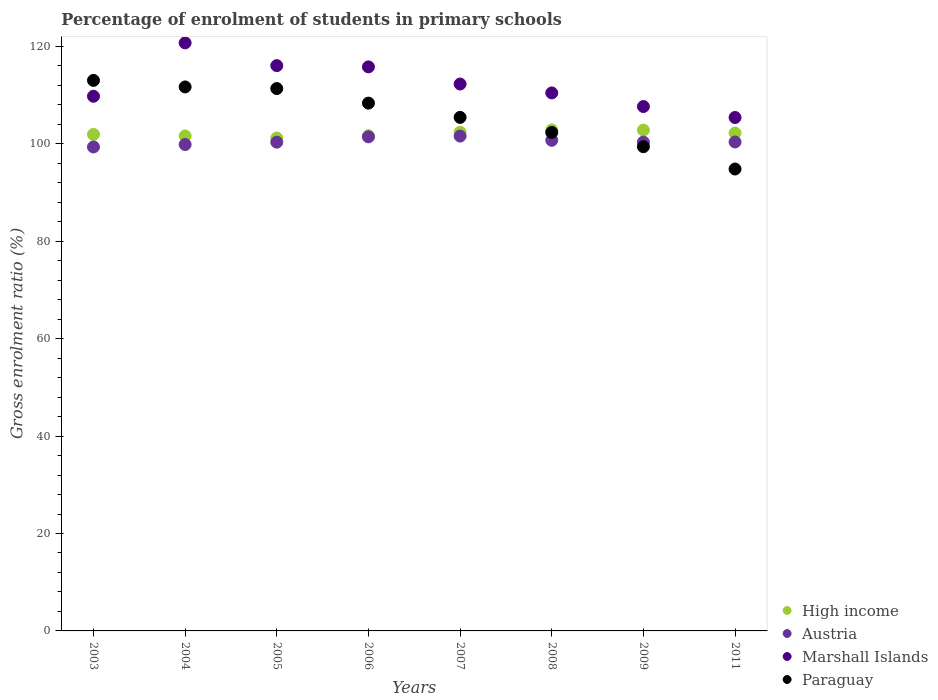Is the number of dotlines equal to the number of legend labels?
Offer a very short reply. Yes. What is the percentage of students enrolled in primary schools in Austria in 2005?
Your answer should be very brief. 100.33. Across all years, what is the maximum percentage of students enrolled in primary schools in Marshall Islands?
Keep it short and to the point. 120.72. Across all years, what is the minimum percentage of students enrolled in primary schools in Austria?
Your response must be concise. 99.35. In which year was the percentage of students enrolled in primary schools in High income maximum?
Keep it short and to the point. 2008. What is the total percentage of students enrolled in primary schools in Austria in the graph?
Offer a terse response. 804.01. What is the difference between the percentage of students enrolled in primary schools in Paraguay in 2003 and that in 2007?
Your response must be concise. 7.59. What is the difference between the percentage of students enrolled in primary schools in Marshall Islands in 2011 and the percentage of students enrolled in primary schools in Paraguay in 2004?
Your answer should be very brief. -6.27. What is the average percentage of students enrolled in primary schools in High income per year?
Offer a terse response. 102.08. In the year 2009, what is the difference between the percentage of students enrolled in primary schools in Austria and percentage of students enrolled in primary schools in Paraguay?
Make the answer very short. 0.94. In how many years, is the percentage of students enrolled in primary schools in High income greater than 116 %?
Keep it short and to the point. 0. What is the ratio of the percentage of students enrolled in primary schools in Paraguay in 2003 to that in 2011?
Make the answer very short. 1.19. Is the difference between the percentage of students enrolled in primary schools in Austria in 2003 and 2009 greater than the difference between the percentage of students enrolled in primary schools in Paraguay in 2003 and 2009?
Your answer should be compact. No. What is the difference between the highest and the second highest percentage of students enrolled in primary schools in High income?
Provide a succinct answer. 0.03. What is the difference between the highest and the lowest percentage of students enrolled in primary schools in Austria?
Provide a short and direct response. 2.23. In how many years, is the percentage of students enrolled in primary schools in Marshall Islands greater than the average percentage of students enrolled in primary schools in Marshall Islands taken over all years?
Ensure brevity in your answer.  4. Is it the case that in every year, the sum of the percentage of students enrolled in primary schools in Austria and percentage of students enrolled in primary schools in High income  is greater than the sum of percentage of students enrolled in primary schools in Marshall Islands and percentage of students enrolled in primary schools in Paraguay?
Offer a very short reply. No. Does the percentage of students enrolled in primary schools in Paraguay monotonically increase over the years?
Your answer should be compact. No. Is the percentage of students enrolled in primary schools in Austria strictly greater than the percentage of students enrolled in primary schools in Marshall Islands over the years?
Ensure brevity in your answer.  No. How many dotlines are there?
Provide a short and direct response. 4. Does the graph contain grids?
Ensure brevity in your answer.  No. What is the title of the graph?
Your answer should be very brief. Percentage of enrolment of students in primary schools. Does "Bahamas" appear as one of the legend labels in the graph?
Your answer should be very brief. No. What is the label or title of the X-axis?
Give a very brief answer. Years. What is the Gross enrolment ratio (%) of High income in 2003?
Your answer should be compact. 101.93. What is the Gross enrolment ratio (%) of Austria in 2003?
Offer a very short reply. 99.35. What is the Gross enrolment ratio (%) in Marshall Islands in 2003?
Provide a short and direct response. 109.76. What is the Gross enrolment ratio (%) in Paraguay in 2003?
Make the answer very short. 113.02. What is the Gross enrolment ratio (%) in High income in 2004?
Your answer should be very brief. 101.62. What is the Gross enrolment ratio (%) in Austria in 2004?
Your answer should be very brief. 99.85. What is the Gross enrolment ratio (%) of Marshall Islands in 2004?
Give a very brief answer. 120.72. What is the Gross enrolment ratio (%) of Paraguay in 2004?
Offer a very short reply. 111.67. What is the Gross enrolment ratio (%) in High income in 2005?
Provide a short and direct response. 101.19. What is the Gross enrolment ratio (%) of Austria in 2005?
Provide a short and direct response. 100.33. What is the Gross enrolment ratio (%) of Marshall Islands in 2005?
Give a very brief answer. 116.05. What is the Gross enrolment ratio (%) of Paraguay in 2005?
Your answer should be very brief. 111.34. What is the Gross enrolment ratio (%) in High income in 2006?
Offer a very short reply. 101.66. What is the Gross enrolment ratio (%) of Austria in 2006?
Give a very brief answer. 101.43. What is the Gross enrolment ratio (%) in Marshall Islands in 2006?
Keep it short and to the point. 115.79. What is the Gross enrolment ratio (%) in Paraguay in 2006?
Offer a very short reply. 108.35. What is the Gross enrolment ratio (%) of High income in 2007?
Your response must be concise. 102.36. What is the Gross enrolment ratio (%) of Austria in 2007?
Give a very brief answer. 101.59. What is the Gross enrolment ratio (%) in Marshall Islands in 2007?
Your answer should be compact. 112.27. What is the Gross enrolment ratio (%) of Paraguay in 2007?
Offer a terse response. 105.42. What is the Gross enrolment ratio (%) of High income in 2008?
Offer a terse response. 102.84. What is the Gross enrolment ratio (%) in Austria in 2008?
Your answer should be compact. 100.72. What is the Gross enrolment ratio (%) in Marshall Islands in 2008?
Ensure brevity in your answer.  110.45. What is the Gross enrolment ratio (%) of Paraguay in 2008?
Make the answer very short. 102.34. What is the Gross enrolment ratio (%) in High income in 2009?
Make the answer very short. 102.81. What is the Gross enrolment ratio (%) in Austria in 2009?
Your response must be concise. 100.35. What is the Gross enrolment ratio (%) in Marshall Islands in 2009?
Your response must be concise. 107.65. What is the Gross enrolment ratio (%) of Paraguay in 2009?
Your answer should be compact. 99.41. What is the Gross enrolment ratio (%) in High income in 2011?
Make the answer very short. 102.21. What is the Gross enrolment ratio (%) in Austria in 2011?
Keep it short and to the point. 100.38. What is the Gross enrolment ratio (%) in Marshall Islands in 2011?
Give a very brief answer. 105.4. What is the Gross enrolment ratio (%) in Paraguay in 2011?
Give a very brief answer. 94.83. Across all years, what is the maximum Gross enrolment ratio (%) of High income?
Give a very brief answer. 102.84. Across all years, what is the maximum Gross enrolment ratio (%) in Austria?
Provide a succinct answer. 101.59. Across all years, what is the maximum Gross enrolment ratio (%) of Marshall Islands?
Your answer should be very brief. 120.72. Across all years, what is the maximum Gross enrolment ratio (%) in Paraguay?
Your answer should be compact. 113.02. Across all years, what is the minimum Gross enrolment ratio (%) of High income?
Offer a terse response. 101.19. Across all years, what is the minimum Gross enrolment ratio (%) in Austria?
Your answer should be very brief. 99.35. Across all years, what is the minimum Gross enrolment ratio (%) of Marshall Islands?
Offer a terse response. 105.4. Across all years, what is the minimum Gross enrolment ratio (%) of Paraguay?
Offer a terse response. 94.83. What is the total Gross enrolment ratio (%) in High income in the graph?
Offer a terse response. 816.63. What is the total Gross enrolment ratio (%) in Austria in the graph?
Provide a succinct answer. 804.01. What is the total Gross enrolment ratio (%) of Marshall Islands in the graph?
Ensure brevity in your answer.  898.1. What is the total Gross enrolment ratio (%) of Paraguay in the graph?
Provide a short and direct response. 846.38. What is the difference between the Gross enrolment ratio (%) in High income in 2003 and that in 2004?
Make the answer very short. 0.31. What is the difference between the Gross enrolment ratio (%) of Austria in 2003 and that in 2004?
Offer a terse response. -0.5. What is the difference between the Gross enrolment ratio (%) in Marshall Islands in 2003 and that in 2004?
Give a very brief answer. -10.96. What is the difference between the Gross enrolment ratio (%) in Paraguay in 2003 and that in 2004?
Ensure brevity in your answer.  1.34. What is the difference between the Gross enrolment ratio (%) in High income in 2003 and that in 2005?
Keep it short and to the point. 0.74. What is the difference between the Gross enrolment ratio (%) in Austria in 2003 and that in 2005?
Ensure brevity in your answer.  -0.98. What is the difference between the Gross enrolment ratio (%) of Marshall Islands in 2003 and that in 2005?
Make the answer very short. -6.29. What is the difference between the Gross enrolment ratio (%) of Paraguay in 2003 and that in 2005?
Make the answer very short. 1.68. What is the difference between the Gross enrolment ratio (%) of High income in 2003 and that in 2006?
Offer a very short reply. 0.27. What is the difference between the Gross enrolment ratio (%) of Austria in 2003 and that in 2006?
Make the answer very short. -2.08. What is the difference between the Gross enrolment ratio (%) in Marshall Islands in 2003 and that in 2006?
Give a very brief answer. -6.03. What is the difference between the Gross enrolment ratio (%) of Paraguay in 2003 and that in 2006?
Offer a very short reply. 4.67. What is the difference between the Gross enrolment ratio (%) of High income in 2003 and that in 2007?
Your answer should be compact. -0.43. What is the difference between the Gross enrolment ratio (%) in Austria in 2003 and that in 2007?
Offer a very short reply. -2.23. What is the difference between the Gross enrolment ratio (%) of Marshall Islands in 2003 and that in 2007?
Offer a terse response. -2.51. What is the difference between the Gross enrolment ratio (%) in Paraguay in 2003 and that in 2007?
Provide a short and direct response. 7.59. What is the difference between the Gross enrolment ratio (%) in High income in 2003 and that in 2008?
Your answer should be compact. -0.91. What is the difference between the Gross enrolment ratio (%) of Austria in 2003 and that in 2008?
Make the answer very short. -1.37. What is the difference between the Gross enrolment ratio (%) of Marshall Islands in 2003 and that in 2008?
Your response must be concise. -0.69. What is the difference between the Gross enrolment ratio (%) in Paraguay in 2003 and that in 2008?
Your answer should be very brief. 10.68. What is the difference between the Gross enrolment ratio (%) in High income in 2003 and that in 2009?
Your answer should be compact. -0.89. What is the difference between the Gross enrolment ratio (%) in Austria in 2003 and that in 2009?
Give a very brief answer. -0.99. What is the difference between the Gross enrolment ratio (%) in Marshall Islands in 2003 and that in 2009?
Offer a very short reply. 2.11. What is the difference between the Gross enrolment ratio (%) of Paraguay in 2003 and that in 2009?
Offer a terse response. 13.61. What is the difference between the Gross enrolment ratio (%) in High income in 2003 and that in 2011?
Provide a succinct answer. -0.28. What is the difference between the Gross enrolment ratio (%) of Austria in 2003 and that in 2011?
Provide a succinct answer. -1.02. What is the difference between the Gross enrolment ratio (%) in Marshall Islands in 2003 and that in 2011?
Your response must be concise. 4.36. What is the difference between the Gross enrolment ratio (%) in Paraguay in 2003 and that in 2011?
Offer a very short reply. 18.19. What is the difference between the Gross enrolment ratio (%) of High income in 2004 and that in 2005?
Your answer should be compact. 0.42. What is the difference between the Gross enrolment ratio (%) in Austria in 2004 and that in 2005?
Ensure brevity in your answer.  -0.48. What is the difference between the Gross enrolment ratio (%) of Marshall Islands in 2004 and that in 2005?
Make the answer very short. 4.67. What is the difference between the Gross enrolment ratio (%) of Paraguay in 2004 and that in 2005?
Offer a very short reply. 0.33. What is the difference between the Gross enrolment ratio (%) of High income in 2004 and that in 2006?
Make the answer very short. -0.04. What is the difference between the Gross enrolment ratio (%) in Austria in 2004 and that in 2006?
Your response must be concise. -1.58. What is the difference between the Gross enrolment ratio (%) in Marshall Islands in 2004 and that in 2006?
Make the answer very short. 4.93. What is the difference between the Gross enrolment ratio (%) in Paraguay in 2004 and that in 2006?
Offer a terse response. 3.32. What is the difference between the Gross enrolment ratio (%) of High income in 2004 and that in 2007?
Your answer should be very brief. -0.75. What is the difference between the Gross enrolment ratio (%) in Austria in 2004 and that in 2007?
Provide a short and direct response. -1.73. What is the difference between the Gross enrolment ratio (%) in Marshall Islands in 2004 and that in 2007?
Make the answer very short. 8.45. What is the difference between the Gross enrolment ratio (%) in Paraguay in 2004 and that in 2007?
Make the answer very short. 6.25. What is the difference between the Gross enrolment ratio (%) in High income in 2004 and that in 2008?
Ensure brevity in your answer.  -1.22. What is the difference between the Gross enrolment ratio (%) in Austria in 2004 and that in 2008?
Your answer should be very brief. -0.87. What is the difference between the Gross enrolment ratio (%) of Marshall Islands in 2004 and that in 2008?
Your answer should be compact. 10.27. What is the difference between the Gross enrolment ratio (%) of Paraguay in 2004 and that in 2008?
Make the answer very short. 9.34. What is the difference between the Gross enrolment ratio (%) in High income in 2004 and that in 2009?
Your response must be concise. -1.2. What is the difference between the Gross enrolment ratio (%) of Austria in 2004 and that in 2009?
Provide a succinct answer. -0.49. What is the difference between the Gross enrolment ratio (%) of Marshall Islands in 2004 and that in 2009?
Offer a very short reply. 13.07. What is the difference between the Gross enrolment ratio (%) in Paraguay in 2004 and that in 2009?
Provide a succinct answer. 12.26. What is the difference between the Gross enrolment ratio (%) in High income in 2004 and that in 2011?
Give a very brief answer. -0.6. What is the difference between the Gross enrolment ratio (%) of Austria in 2004 and that in 2011?
Your response must be concise. -0.52. What is the difference between the Gross enrolment ratio (%) of Marshall Islands in 2004 and that in 2011?
Offer a terse response. 15.32. What is the difference between the Gross enrolment ratio (%) in Paraguay in 2004 and that in 2011?
Offer a terse response. 16.85. What is the difference between the Gross enrolment ratio (%) in High income in 2005 and that in 2006?
Your answer should be compact. -0.47. What is the difference between the Gross enrolment ratio (%) of Austria in 2005 and that in 2006?
Ensure brevity in your answer.  -1.1. What is the difference between the Gross enrolment ratio (%) in Marshall Islands in 2005 and that in 2006?
Your response must be concise. 0.26. What is the difference between the Gross enrolment ratio (%) in Paraguay in 2005 and that in 2006?
Keep it short and to the point. 2.99. What is the difference between the Gross enrolment ratio (%) of High income in 2005 and that in 2007?
Your response must be concise. -1.17. What is the difference between the Gross enrolment ratio (%) of Austria in 2005 and that in 2007?
Your response must be concise. -1.25. What is the difference between the Gross enrolment ratio (%) of Marshall Islands in 2005 and that in 2007?
Your answer should be compact. 3.78. What is the difference between the Gross enrolment ratio (%) in Paraguay in 2005 and that in 2007?
Ensure brevity in your answer.  5.92. What is the difference between the Gross enrolment ratio (%) in High income in 2005 and that in 2008?
Offer a terse response. -1.65. What is the difference between the Gross enrolment ratio (%) in Austria in 2005 and that in 2008?
Provide a succinct answer. -0.39. What is the difference between the Gross enrolment ratio (%) in Marshall Islands in 2005 and that in 2008?
Provide a succinct answer. 5.6. What is the difference between the Gross enrolment ratio (%) of Paraguay in 2005 and that in 2008?
Offer a very short reply. 9.01. What is the difference between the Gross enrolment ratio (%) in High income in 2005 and that in 2009?
Offer a very short reply. -1.62. What is the difference between the Gross enrolment ratio (%) of Austria in 2005 and that in 2009?
Offer a terse response. -0.01. What is the difference between the Gross enrolment ratio (%) of Marshall Islands in 2005 and that in 2009?
Ensure brevity in your answer.  8.4. What is the difference between the Gross enrolment ratio (%) of Paraguay in 2005 and that in 2009?
Provide a short and direct response. 11.93. What is the difference between the Gross enrolment ratio (%) of High income in 2005 and that in 2011?
Make the answer very short. -1.02. What is the difference between the Gross enrolment ratio (%) of Austria in 2005 and that in 2011?
Your answer should be very brief. -0.04. What is the difference between the Gross enrolment ratio (%) of Marshall Islands in 2005 and that in 2011?
Ensure brevity in your answer.  10.65. What is the difference between the Gross enrolment ratio (%) of Paraguay in 2005 and that in 2011?
Ensure brevity in your answer.  16.52. What is the difference between the Gross enrolment ratio (%) of High income in 2006 and that in 2007?
Your answer should be very brief. -0.71. What is the difference between the Gross enrolment ratio (%) of Austria in 2006 and that in 2007?
Offer a very short reply. -0.15. What is the difference between the Gross enrolment ratio (%) in Marshall Islands in 2006 and that in 2007?
Provide a short and direct response. 3.52. What is the difference between the Gross enrolment ratio (%) of Paraguay in 2006 and that in 2007?
Your response must be concise. 2.93. What is the difference between the Gross enrolment ratio (%) of High income in 2006 and that in 2008?
Your answer should be compact. -1.18. What is the difference between the Gross enrolment ratio (%) of Austria in 2006 and that in 2008?
Make the answer very short. 0.71. What is the difference between the Gross enrolment ratio (%) of Marshall Islands in 2006 and that in 2008?
Keep it short and to the point. 5.35. What is the difference between the Gross enrolment ratio (%) of Paraguay in 2006 and that in 2008?
Offer a very short reply. 6.02. What is the difference between the Gross enrolment ratio (%) of High income in 2006 and that in 2009?
Ensure brevity in your answer.  -1.16. What is the difference between the Gross enrolment ratio (%) of Austria in 2006 and that in 2009?
Offer a terse response. 1.09. What is the difference between the Gross enrolment ratio (%) of Marshall Islands in 2006 and that in 2009?
Your answer should be very brief. 8.14. What is the difference between the Gross enrolment ratio (%) in Paraguay in 2006 and that in 2009?
Offer a terse response. 8.94. What is the difference between the Gross enrolment ratio (%) of High income in 2006 and that in 2011?
Offer a very short reply. -0.55. What is the difference between the Gross enrolment ratio (%) of Austria in 2006 and that in 2011?
Your response must be concise. 1.06. What is the difference between the Gross enrolment ratio (%) in Marshall Islands in 2006 and that in 2011?
Ensure brevity in your answer.  10.39. What is the difference between the Gross enrolment ratio (%) of Paraguay in 2006 and that in 2011?
Provide a succinct answer. 13.53. What is the difference between the Gross enrolment ratio (%) of High income in 2007 and that in 2008?
Your answer should be very brief. -0.48. What is the difference between the Gross enrolment ratio (%) of Austria in 2007 and that in 2008?
Provide a succinct answer. 0.86. What is the difference between the Gross enrolment ratio (%) of Marshall Islands in 2007 and that in 2008?
Provide a short and direct response. 1.83. What is the difference between the Gross enrolment ratio (%) of Paraguay in 2007 and that in 2008?
Provide a short and direct response. 3.09. What is the difference between the Gross enrolment ratio (%) of High income in 2007 and that in 2009?
Offer a very short reply. -0.45. What is the difference between the Gross enrolment ratio (%) in Austria in 2007 and that in 2009?
Your response must be concise. 1.24. What is the difference between the Gross enrolment ratio (%) of Marshall Islands in 2007 and that in 2009?
Give a very brief answer. 4.62. What is the difference between the Gross enrolment ratio (%) of Paraguay in 2007 and that in 2009?
Ensure brevity in your answer.  6.02. What is the difference between the Gross enrolment ratio (%) in High income in 2007 and that in 2011?
Ensure brevity in your answer.  0.15. What is the difference between the Gross enrolment ratio (%) in Austria in 2007 and that in 2011?
Make the answer very short. 1.21. What is the difference between the Gross enrolment ratio (%) of Marshall Islands in 2007 and that in 2011?
Your response must be concise. 6.87. What is the difference between the Gross enrolment ratio (%) in Paraguay in 2007 and that in 2011?
Offer a terse response. 10.6. What is the difference between the Gross enrolment ratio (%) of High income in 2008 and that in 2009?
Your response must be concise. 0.03. What is the difference between the Gross enrolment ratio (%) of Austria in 2008 and that in 2009?
Give a very brief answer. 0.38. What is the difference between the Gross enrolment ratio (%) in Marshall Islands in 2008 and that in 2009?
Give a very brief answer. 2.79. What is the difference between the Gross enrolment ratio (%) in Paraguay in 2008 and that in 2009?
Your response must be concise. 2.93. What is the difference between the Gross enrolment ratio (%) of High income in 2008 and that in 2011?
Make the answer very short. 0.63. What is the difference between the Gross enrolment ratio (%) of Austria in 2008 and that in 2011?
Offer a very short reply. 0.34. What is the difference between the Gross enrolment ratio (%) of Marshall Islands in 2008 and that in 2011?
Make the answer very short. 5.04. What is the difference between the Gross enrolment ratio (%) of Paraguay in 2008 and that in 2011?
Give a very brief answer. 7.51. What is the difference between the Gross enrolment ratio (%) in High income in 2009 and that in 2011?
Your answer should be compact. 0.6. What is the difference between the Gross enrolment ratio (%) in Austria in 2009 and that in 2011?
Ensure brevity in your answer.  -0.03. What is the difference between the Gross enrolment ratio (%) of Marshall Islands in 2009 and that in 2011?
Your answer should be very brief. 2.25. What is the difference between the Gross enrolment ratio (%) in Paraguay in 2009 and that in 2011?
Offer a very short reply. 4.58. What is the difference between the Gross enrolment ratio (%) in High income in 2003 and the Gross enrolment ratio (%) in Austria in 2004?
Ensure brevity in your answer.  2.08. What is the difference between the Gross enrolment ratio (%) in High income in 2003 and the Gross enrolment ratio (%) in Marshall Islands in 2004?
Your answer should be compact. -18.79. What is the difference between the Gross enrolment ratio (%) of High income in 2003 and the Gross enrolment ratio (%) of Paraguay in 2004?
Your response must be concise. -9.74. What is the difference between the Gross enrolment ratio (%) in Austria in 2003 and the Gross enrolment ratio (%) in Marshall Islands in 2004?
Provide a short and direct response. -21.37. What is the difference between the Gross enrolment ratio (%) of Austria in 2003 and the Gross enrolment ratio (%) of Paraguay in 2004?
Provide a short and direct response. -12.32. What is the difference between the Gross enrolment ratio (%) of Marshall Islands in 2003 and the Gross enrolment ratio (%) of Paraguay in 2004?
Offer a terse response. -1.91. What is the difference between the Gross enrolment ratio (%) in High income in 2003 and the Gross enrolment ratio (%) in Austria in 2005?
Provide a short and direct response. 1.6. What is the difference between the Gross enrolment ratio (%) of High income in 2003 and the Gross enrolment ratio (%) of Marshall Islands in 2005?
Offer a very short reply. -14.12. What is the difference between the Gross enrolment ratio (%) of High income in 2003 and the Gross enrolment ratio (%) of Paraguay in 2005?
Your answer should be very brief. -9.41. What is the difference between the Gross enrolment ratio (%) in Austria in 2003 and the Gross enrolment ratio (%) in Marshall Islands in 2005?
Offer a very short reply. -16.7. What is the difference between the Gross enrolment ratio (%) in Austria in 2003 and the Gross enrolment ratio (%) in Paraguay in 2005?
Your response must be concise. -11.99. What is the difference between the Gross enrolment ratio (%) of Marshall Islands in 2003 and the Gross enrolment ratio (%) of Paraguay in 2005?
Your response must be concise. -1.58. What is the difference between the Gross enrolment ratio (%) of High income in 2003 and the Gross enrolment ratio (%) of Austria in 2006?
Your response must be concise. 0.5. What is the difference between the Gross enrolment ratio (%) in High income in 2003 and the Gross enrolment ratio (%) in Marshall Islands in 2006?
Your answer should be compact. -13.86. What is the difference between the Gross enrolment ratio (%) of High income in 2003 and the Gross enrolment ratio (%) of Paraguay in 2006?
Keep it short and to the point. -6.42. What is the difference between the Gross enrolment ratio (%) in Austria in 2003 and the Gross enrolment ratio (%) in Marshall Islands in 2006?
Keep it short and to the point. -16.44. What is the difference between the Gross enrolment ratio (%) of Austria in 2003 and the Gross enrolment ratio (%) of Paraguay in 2006?
Your response must be concise. -9. What is the difference between the Gross enrolment ratio (%) in Marshall Islands in 2003 and the Gross enrolment ratio (%) in Paraguay in 2006?
Provide a succinct answer. 1.41. What is the difference between the Gross enrolment ratio (%) in High income in 2003 and the Gross enrolment ratio (%) in Austria in 2007?
Give a very brief answer. 0.34. What is the difference between the Gross enrolment ratio (%) of High income in 2003 and the Gross enrolment ratio (%) of Marshall Islands in 2007?
Ensure brevity in your answer.  -10.34. What is the difference between the Gross enrolment ratio (%) of High income in 2003 and the Gross enrolment ratio (%) of Paraguay in 2007?
Your response must be concise. -3.49. What is the difference between the Gross enrolment ratio (%) in Austria in 2003 and the Gross enrolment ratio (%) in Marshall Islands in 2007?
Give a very brief answer. -12.92. What is the difference between the Gross enrolment ratio (%) in Austria in 2003 and the Gross enrolment ratio (%) in Paraguay in 2007?
Offer a terse response. -6.07. What is the difference between the Gross enrolment ratio (%) of Marshall Islands in 2003 and the Gross enrolment ratio (%) of Paraguay in 2007?
Offer a very short reply. 4.34. What is the difference between the Gross enrolment ratio (%) in High income in 2003 and the Gross enrolment ratio (%) in Austria in 2008?
Offer a very short reply. 1.21. What is the difference between the Gross enrolment ratio (%) of High income in 2003 and the Gross enrolment ratio (%) of Marshall Islands in 2008?
Keep it short and to the point. -8.52. What is the difference between the Gross enrolment ratio (%) of High income in 2003 and the Gross enrolment ratio (%) of Paraguay in 2008?
Provide a succinct answer. -0.41. What is the difference between the Gross enrolment ratio (%) in Austria in 2003 and the Gross enrolment ratio (%) in Marshall Islands in 2008?
Keep it short and to the point. -11.09. What is the difference between the Gross enrolment ratio (%) in Austria in 2003 and the Gross enrolment ratio (%) in Paraguay in 2008?
Provide a succinct answer. -2.98. What is the difference between the Gross enrolment ratio (%) in Marshall Islands in 2003 and the Gross enrolment ratio (%) in Paraguay in 2008?
Provide a succinct answer. 7.42. What is the difference between the Gross enrolment ratio (%) of High income in 2003 and the Gross enrolment ratio (%) of Austria in 2009?
Ensure brevity in your answer.  1.58. What is the difference between the Gross enrolment ratio (%) in High income in 2003 and the Gross enrolment ratio (%) in Marshall Islands in 2009?
Make the answer very short. -5.72. What is the difference between the Gross enrolment ratio (%) in High income in 2003 and the Gross enrolment ratio (%) in Paraguay in 2009?
Make the answer very short. 2.52. What is the difference between the Gross enrolment ratio (%) of Austria in 2003 and the Gross enrolment ratio (%) of Marshall Islands in 2009?
Offer a very short reply. -8.3. What is the difference between the Gross enrolment ratio (%) of Austria in 2003 and the Gross enrolment ratio (%) of Paraguay in 2009?
Keep it short and to the point. -0.06. What is the difference between the Gross enrolment ratio (%) in Marshall Islands in 2003 and the Gross enrolment ratio (%) in Paraguay in 2009?
Your answer should be very brief. 10.35. What is the difference between the Gross enrolment ratio (%) in High income in 2003 and the Gross enrolment ratio (%) in Austria in 2011?
Give a very brief answer. 1.55. What is the difference between the Gross enrolment ratio (%) of High income in 2003 and the Gross enrolment ratio (%) of Marshall Islands in 2011?
Your answer should be compact. -3.47. What is the difference between the Gross enrolment ratio (%) of High income in 2003 and the Gross enrolment ratio (%) of Paraguay in 2011?
Give a very brief answer. 7.1. What is the difference between the Gross enrolment ratio (%) of Austria in 2003 and the Gross enrolment ratio (%) of Marshall Islands in 2011?
Offer a terse response. -6.05. What is the difference between the Gross enrolment ratio (%) of Austria in 2003 and the Gross enrolment ratio (%) of Paraguay in 2011?
Keep it short and to the point. 4.53. What is the difference between the Gross enrolment ratio (%) of Marshall Islands in 2003 and the Gross enrolment ratio (%) of Paraguay in 2011?
Make the answer very short. 14.93. What is the difference between the Gross enrolment ratio (%) of High income in 2004 and the Gross enrolment ratio (%) of Austria in 2005?
Give a very brief answer. 1.28. What is the difference between the Gross enrolment ratio (%) in High income in 2004 and the Gross enrolment ratio (%) in Marshall Islands in 2005?
Your answer should be compact. -14.43. What is the difference between the Gross enrolment ratio (%) in High income in 2004 and the Gross enrolment ratio (%) in Paraguay in 2005?
Give a very brief answer. -9.73. What is the difference between the Gross enrolment ratio (%) in Austria in 2004 and the Gross enrolment ratio (%) in Marshall Islands in 2005?
Your answer should be compact. -16.2. What is the difference between the Gross enrolment ratio (%) in Austria in 2004 and the Gross enrolment ratio (%) in Paraguay in 2005?
Your answer should be very brief. -11.49. What is the difference between the Gross enrolment ratio (%) of Marshall Islands in 2004 and the Gross enrolment ratio (%) of Paraguay in 2005?
Offer a terse response. 9.38. What is the difference between the Gross enrolment ratio (%) of High income in 2004 and the Gross enrolment ratio (%) of Austria in 2006?
Make the answer very short. 0.18. What is the difference between the Gross enrolment ratio (%) of High income in 2004 and the Gross enrolment ratio (%) of Marshall Islands in 2006?
Provide a succinct answer. -14.18. What is the difference between the Gross enrolment ratio (%) of High income in 2004 and the Gross enrolment ratio (%) of Paraguay in 2006?
Provide a short and direct response. -6.74. What is the difference between the Gross enrolment ratio (%) of Austria in 2004 and the Gross enrolment ratio (%) of Marshall Islands in 2006?
Offer a terse response. -15.94. What is the difference between the Gross enrolment ratio (%) of Austria in 2004 and the Gross enrolment ratio (%) of Paraguay in 2006?
Provide a succinct answer. -8.5. What is the difference between the Gross enrolment ratio (%) in Marshall Islands in 2004 and the Gross enrolment ratio (%) in Paraguay in 2006?
Keep it short and to the point. 12.37. What is the difference between the Gross enrolment ratio (%) of High income in 2004 and the Gross enrolment ratio (%) of Austria in 2007?
Keep it short and to the point. 0.03. What is the difference between the Gross enrolment ratio (%) of High income in 2004 and the Gross enrolment ratio (%) of Marshall Islands in 2007?
Make the answer very short. -10.66. What is the difference between the Gross enrolment ratio (%) in High income in 2004 and the Gross enrolment ratio (%) in Paraguay in 2007?
Make the answer very short. -3.81. What is the difference between the Gross enrolment ratio (%) of Austria in 2004 and the Gross enrolment ratio (%) of Marshall Islands in 2007?
Keep it short and to the point. -12.42. What is the difference between the Gross enrolment ratio (%) of Austria in 2004 and the Gross enrolment ratio (%) of Paraguay in 2007?
Offer a very short reply. -5.57. What is the difference between the Gross enrolment ratio (%) of Marshall Islands in 2004 and the Gross enrolment ratio (%) of Paraguay in 2007?
Provide a short and direct response. 15.3. What is the difference between the Gross enrolment ratio (%) in High income in 2004 and the Gross enrolment ratio (%) in Austria in 2008?
Offer a very short reply. 0.89. What is the difference between the Gross enrolment ratio (%) in High income in 2004 and the Gross enrolment ratio (%) in Marshall Islands in 2008?
Offer a terse response. -8.83. What is the difference between the Gross enrolment ratio (%) in High income in 2004 and the Gross enrolment ratio (%) in Paraguay in 2008?
Offer a very short reply. -0.72. What is the difference between the Gross enrolment ratio (%) of Austria in 2004 and the Gross enrolment ratio (%) of Marshall Islands in 2008?
Your answer should be compact. -10.59. What is the difference between the Gross enrolment ratio (%) of Austria in 2004 and the Gross enrolment ratio (%) of Paraguay in 2008?
Your answer should be compact. -2.48. What is the difference between the Gross enrolment ratio (%) in Marshall Islands in 2004 and the Gross enrolment ratio (%) in Paraguay in 2008?
Your answer should be compact. 18.38. What is the difference between the Gross enrolment ratio (%) in High income in 2004 and the Gross enrolment ratio (%) in Austria in 2009?
Your answer should be very brief. 1.27. What is the difference between the Gross enrolment ratio (%) of High income in 2004 and the Gross enrolment ratio (%) of Marshall Islands in 2009?
Your answer should be very brief. -6.04. What is the difference between the Gross enrolment ratio (%) of High income in 2004 and the Gross enrolment ratio (%) of Paraguay in 2009?
Your answer should be very brief. 2.21. What is the difference between the Gross enrolment ratio (%) in Austria in 2004 and the Gross enrolment ratio (%) in Marshall Islands in 2009?
Offer a very short reply. -7.8. What is the difference between the Gross enrolment ratio (%) of Austria in 2004 and the Gross enrolment ratio (%) of Paraguay in 2009?
Keep it short and to the point. 0.45. What is the difference between the Gross enrolment ratio (%) of Marshall Islands in 2004 and the Gross enrolment ratio (%) of Paraguay in 2009?
Give a very brief answer. 21.31. What is the difference between the Gross enrolment ratio (%) of High income in 2004 and the Gross enrolment ratio (%) of Austria in 2011?
Offer a terse response. 1.24. What is the difference between the Gross enrolment ratio (%) of High income in 2004 and the Gross enrolment ratio (%) of Marshall Islands in 2011?
Keep it short and to the point. -3.79. What is the difference between the Gross enrolment ratio (%) in High income in 2004 and the Gross enrolment ratio (%) in Paraguay in 2011?
Offer a very short reply. 6.79. What is the difference between the Gross enrolment ratio (%) in Austria in 2004 and the Gross enrolment ratio (%) in Marshall Islands in 2011?
Offer a terse response. -5.55. What is the difference between the Gross enrolment ratio (%) in Austria in 2004 and the Gross enrolment ratio (%) in Paraguay in 2011?
Provide a short and direct response. 5.03. What is the difference between the Gross enrolment ratio (%) of Marshall Islands in 2004 and the Gross enrolment ratio (%) of Paraguay in 2011?
Keep it short and to the point. 25.89. What is the difference between the Gross enrolment ratio (%) of High income in 2005 and the Gross enrolment ratio (%) of Austria in 2006?
Offer a very short reply. -0.24. What is the difference between the Gross enrolment ratio (%) in High income in 2005 and the Gross enrolment ratio (%) in Marshall Islands in 2006?
Give a very brief answer. -14.6. What is the difference between the Gross enrolment ratio (%) of High income in 2005 and the Gross enrolment ratio (%) of Paraguay in 2006?
Your answer should be very brief. -7.16. What is the difference between the Gross enrolment ratio (%) in Austria in 2005 and the Gross enrolment ratio (%) in Marshall Islands in 2006?
Ensure brevity in your answer.  -15.46. What is the difference between the Gross enrolment ratio (%) in Austria in 2005 and the Gross enrolment ratio (%) in Paraguay in 2006?
Your response must be concise. -8.02. What is the difference between the Gross enrolment ratio (%) in Marshall Islands in 2005 and the Gross enrolment ratio (%) in Paraguay in 2006?
Offer a very short reply. 7.7. What is the difference between the Gross enrolment ratio (%) in High income in 2005 and the Gross enrolment ratio (%) in Austria in 2007?
Make the answer very short. -0.39. What is the difference between the Gross enrolment ratio (%) of High income in 2005 and the Gross enrolment ratio (%) of Marshall Islands in 2007?
Keep it short and to the point. -11.08. What is the difference between the Gross enrolment ratio (%) in High income in 2005 and the Gross enrolment ratio (%) in Paraguay in 2007?
Provide a short and direct response. -4.23. What is the difference between the Gross enrolment ratio (%) of Austria in 2005 and the Gross enrolment ratio (%) of Marshall Islands in 2007?
Keep it short and to the point. -11.94. What is the difference between the Gross enrolment ratio (%) in Austria in 2005 and the Gross enrolment ratio (%) in Paraguay in 2007?
Provide a short and direct response. -5.09. What is the difference between the Gross enrolment ratio (%) of Marshall Islands in 2005 and the Gross enrolment ratio (%) of Paraguay in 2007?
Keep it short and to the point. 10.63. What is the difference between the Gross enrolment ratio (%) of High income in 2005 and the Gross enrolment ratio (%) of Austria in 2008?
Keep it short and to the point. 0.47. What is the difference between the Gross enrolment ratio (%) in High income in 2005 and the Gross enrolment ratio (%) in Marshall Islands in 2008?
Make the answer very short. -9.25. What is the difference between the Gross enrolment ratio (%) of High income in 2005 and the Gross enrolment ratio (%) of Paraguay in 2008?
Ensure brevity in your answer.  -1.14. What is the difference between the Gross enrolment ratio (%) in Austria in 2005 and the Gross enrolment ratio (%) in Marshall Islands in 2008?
Provide a short and direct response. -10.11. What is the difference between the Gross enrolment ratio (%) in Austria in 2005 and the Gross enrolment ratio (%) in Paraguay in 2008?
Your response must be concise. -2. What is the difference between the Gross enrolment ratio (%) in Marshall Islands in 2005 and the Gross enrolment ratio (%) in Paraguay in 2008?
Ensure brevity in your answer.  13.71. What is the difference between the Gross enrolment ratio (%) in High income in 2005 and the Gross enrolment ratio (%) in Austria in 2009?
Your answer should be compact. 0.85. What is the difference between the Gross enrolment ratio (%) of High income in 2005 and the Gross enrolment ratio (%) of Marshall Islands in 2009?
Your answer should be very brief. -6.46. What is the difference between the Gross enrolment ratio (%) in High income in 2005 and the Gross enrolment ratio (%) in Paraguay in 2009?
Make the answer very short. 1.78. What is the difference between the Gross enrolment ratio (%) in Austria in 2005 and the Gross enrolment ratio (%) in Marshall Islands in 2009?
Give a very brief answer. -7.32. What is the difference between the Gross enrolment ratio (%) in Austria in 2005 and the Gross enrolment ratio (%) in Paraguay in 2009?
Give a very brief answer. 0.93. What is the difference between the Gross enrolment ratio (%) in Marshall Islands in 2005 and the Gross enrolment ratio (%) in Paraguay in 2009?
Your answer should be compact. 16.64. What is the difference between the Gross enrolment ratio (%) of High income in 2005 and the Gross enrolment ratio (%) of Austria in 2011?
Offer a very short reply. 0.82. What is the difference between the Gross enrolment ratio (%) in High income in 2005 and the Gross enrolment ratio (%) in Marshall Islands in 2011?
Keep it short and to the point. -4.21. What is the difference between the Gross enrolment ratio (%) of High income in 2005 and the Gross enrolment ratio (%) of Paraguay in 2011?
Your response must be concise. 6.37. What is the difference between the Gross enrolment ratio (%) of Austria in 2005 and the Gross enrolment ratio (%) of Marshall Islands in 2011?
Give a very brief answer. -5.07. What is the difference between the Gross enrolment ratio (%) of Austria in 2005 and the Gross enrolment ratio (%) of Paraguay in 2011?
Ensure brevity in your answer.  5.51. What is the difference between the Gross enrolment ratio (%) of Marshall Islands in 2005 and the Gross enrolment ratio (%) of Paraguay in 2011?
Offer a terse response. 21.22. What is the difference between the Gross enrolment ratio (%) of High income in 2006 and the Gross enrolment ratio (%) of Austria in 2007?
Provide a succinct answer. 0.07. What is the difference between the Gross enrolment ratio (%) in High income in 2006 and the Gross enrolment ratio (%) in Marshall Islands in 2007?
Your response must be concise. -10.61. What is the difference between the Gross enrolment ratio (%) in High income in 2006 and the Gross enrolment ratio (%) in Paraguay in 2007?
Your answer should be compact. -3.77. What is the difference between the Gross enrolment ratio (%) of Austria in 2006 and the Gross enrolment ratio (%) of Marshall Islands in 2007?
Provide a succinct answer. -10.84. What is the difference between the Gross enrolment ratio (%) in Austria in 2006 and the Gross enrolment ratio (%) in Paraguay in 2007?
Your answer should be compact. -3.99. What is the difference between the Gross enrolment ratio (%) in Marshall Islands in 2006 and the Gross enrolment ratio (%) in Paraguay in 2007?
Keep it short and to the point. 10.37. What is the difference between the Gross enrolment ratio (%) in High income in 2006 and the Gross enrolment ratio (%) in Austria in 2008?
Keep it short and to the point. 0.94. What is the difference between the Gross enrolment ratio (%) of High income in 2006 and the Gross enrolment ratio (%) of Marshall Islands in 2008?
Offer a terse response. -8.79. What is the difference between the Gross enrolment ratio (%) in High income in 2006 and the Gross enrolment ratio (%) in Paraguay in 2008?
Your answer should be very brief. -0.68. What is the difference between the Gross enrolment ratio (%) of Austria in 2006 and the Gross enrolment ratio (%) of Marshall Islands in 2008?
Offer a very short reply. -9.01. What is the difference between the Gross enrolment ratio (%) in Austria in 2006 and the Gross enrolment ratio (%) in Paraguay in 2008?
Keep it short and to the point. -0.9. What is the difference between the Gross enrolment ratio (%) of Marshall Islands in 2006 and the Gross enrolment ratio (%) of Paraguay in 2008?
Ensure brevity in your answer.  13.46. What is the difference between the Gross enrolment ratio (%) of High income in 2006 and the Gross enrolment ratio (%) of Austria in 2009?
Offer a terse response. 1.31. What is the difference between the Gross enrolment ratio (%) in High income in 2006 and the Gross enrolment ratio (%) in Marshall Islands in 2009?
Your answer should be very brief. -5.99. What is the difference between the Gross enrolment ratio (%) of High income in 2006 and the Gross enrolment ratio (%) of Paraguay in 2009?
Ensure brevity in your answer.  2.25. What is the difference between the Gross enrolment ratio (%) of Austria in 2006 and the Gross enrolment ratio (%) of Marshall Islands in 2009?
Your answer should be very brief. -6.22. What is the difference between the Gross enrolment ratio (%) in Austria in 2006 and the Gross enrolment ratio (%) in Paraguay in 2009?
Your response must be concise. 2.03. What is the difference between the Gross enrolment ratio (%) of Marshall Islands in 2006 and the Gross enrolment ratio (%) of Paraguay in 2009?
Give a very brief answer. 16.39. What is the difference between the Gross enrolment ratio (%) in High income in 2006 and the Gross enrolment ratio (%) in Austria in 2011?
Keep it short and to the point. 1.28. What is the difference between the Gross enrolment ratio (%) of High income in 2006 and the Gross enrolment ratio (%) of Marshall Islands in 2011?
Make the answer very short. -3.74. What is the difference between the Gross enrolment ratio (%) of High income in 2006 and the Gross enrolment ratio (%) of Paraguay in 2011?
Make the answer very short. 6.83. What is the difference between the Gross enrolment ratio (%) of Austria in 2006 and the Gross enrolment ratio (%) of Marshall Islands in 2011?
Make the answer very short. -3.97. What is the difference between the Gross enrolment ratio (%) of Austria in 2006 and the Gross enrolment ratio (%) of Paraguay in 2011?
Provide a short and direct response. 6.61. What is the difference between the Gross enrolment ratio (%) in Marshall Islands in 2006 and the Gross enrolment ratio (%) in Paraguay in 2011?
Your answer should be very brief. 20.97. What is the difference between the Gross enrolment ratio (%) of High income in 2007 and the Gross enrolment ratio (%) of Austria in 2008?
Offer a very short reply. 1.64. What is the difference between the Gross enrolment ratio (%) of High income in 2007 and the Gross enrolment ratio (%) of Marshall Islands in 2008?
Provide a short and direct response. -8.08. What is the difference between the Gross enrolment ratio (%) in High income in 2007 and the Gross enrolment ratio (%) in Paraguay in 2008?
Provide a short and direct response. 0.03. What is the difference between the Gross enrolment ratio (%) in Austria in 2007 and the Gross enrolment ratio (%) in Marshall Islands in 2008?
Provide a succinct answer. -8.86. What is the difference between the Gross enrolment ratio (%) of Austria in 2007 and the Gross enrolment ratio (%) of Paraguay in 2008?
Your answer should be very brief. -0.75. What is the difference between the Gross enrolment ratio (%) of Marshall Islands in 2007 and the Gross enrolment ratio (%) of Paraguay in 2008?
Your response must be concise. 9.94. What is the difference between the Gross enrolment ratio (%) in High income in 2007 and the Gross enrolment ratio (%) in Austria in 2009?
Offer a very short reply. 2.02. What is the difference between the Gross enrolment ratio (%) in High income in 2007 and the Gross enrolment ratio (%) in Marshall Islands in 2009?
Make the answer very short. -5.29. What is the difference between the Gross enrolment ratio (%) of High income in 2007 and the Gross enrolment ratio (%) of Paraguay in 2009?
Your answer should be very brief. 2.96. What is the difference between the Gross enrolment ratio (%) in Austria in 2007 and the Gross enrolment ratio (%) in Marshall Islands in 2009?
Offer a very short reply. -6.07. What is the difference between the Gross enrolment ratio (%) in Austria in 2007 and the Gross enrolment ratio (%) in Paraguay in 2009?
Give a very brief answer. 2.18. What is the difference between the Gross enrolment ratio (%) of Marshall Islands in 2007 and the Gross enrolment ratio (%) of Paraguay in 2009?
Keep it short and to the point. 12.86. What is the difference between the Gross enrolment ratio (%) of High income in 2007 and the Gross enrolment ratio (%) of Austria in 2011?
Your response must be concise. 1.99. What is the difference between the Gross enrolment ratio (%) of High income in 2007 and the Gross enrolment ratio (%) of Marshall Islands in 2011?
Give a very brief answer. -3.04. What is the difference between the Gross enrolment ratio (%) of High income in 2007 and the Gross enrolment ratio (%) of Paraguay in 2011?
Offer a terse response. 7.54. What is the difference between the Gross enrolment ratio (%) of Austria in 2007 and the Gross enrolment ratio (%) of Marshall Islands in 2011?
Ensure brevity in your answer.  -3.82. What is the difference between the Gross enrolment ratio (%) in Austria in 2007 and the Gross enrolment ratio (%) in Paraguay in 2011?
Your answer should be very brief. 6.76. What is the difference between the Gross enrolment ratio (%) in Marshall Islands in 2007 and the Gross enrolment ratio (%) in Paraguay in 2011?
Ensure brevity in your answer.  17.45. What is the difference between the Gross enrolment ratio (%) in High income in 2008 and the Gross enrolment ratio (%) in Austria in 2009?
Provide a succinct answer. 2.49. What is the difference between the Gross enrolment ratio (%) in High income in 2008 and the Gross enrolment ratio (%) in Marshall Islands in 2009?
Your answer should be compact. -4.81. What is the difference between the Gross enrolment ratio (%) of High income in 2008 and the Gross enrolment ratio (%) of Paraguay in 2009?
Offer a very short reply. 3.43. What is the difference between the Gross enrolment ratio (%) of Austria in 2008 and the Gross enrolment ratio (%) of Marshall Islands in 2009?
Make the answer very short. -6.93. What is the difference between the Gross enrolment ratio (%) in Austria in 2008 and the Gross enrolment ratio (%) in Paraguay in 2009?
Make the answer very short. 1.31. What is the difference between the Gross enrolment ratio (%) in Marshall Islands in 2008 and the Gross enrolment ratio (%) in Paraguay in 2009?
Keep it short and to the point. 11.04. What is the difference between the Gross enrolment ratio (%) in High income in 2008 and the Gross enrolment ratio (%) in Austria in 2011?
Give a very brief answer. 2.46. What is the difference between the Gross enrolment ratio (%) in High income in 2008 and the Gross enrolment ratio (%) in Marshall Islands in 2011?
Ensure brevity in your answer.  -2.56. What is the difference between the Gross enrolment ratio (%) of High income in 2008 and the Gross enrolment ratio (%) of Paraguay in 2011?
Your response must be concise. 8.01. What is the difference between the Gross enrolment ratio (%) of Austria in 2008 and the Gross enrolment ratio (%) of Marshall Islands in 2011?
Give a very brief answer. -4.68. What is the difference between the Gross enrolment ratio (%) in Austria in 2008 and the Gross enrolment ratio (%) in Paraguay in 2011?
Give a very brief answer. 5.9. What is the difference between the Gross enrolment ratio (%) in Marshall Islands in 2008 and the Gross enrolment ratio (%) in Paraguay in 2011?
Ensure brevity in your answer.  15.62. What is the difference between the Gross enrolment ratio (%) in High income in 2009 and the Gross enrolment ratio (%) in Austria in 2011?
Ensure brevity in your answer.  2.44. What is the difference between the Gross enrolment ratio (%) of High income in 2009 and the Gross enrolment ratio (%) of Marshall Islands in 2011?
Provide a succinct answer. -2.59. What is the difference between the Gross enrolment ratio (%) in High income in 2009 and the Gross enrolment ratio (%) in Paraguay in 2011?
Keep it short and to the point. 7.99. What is the difference between the Gross enrolment ratio (%) in Austria in 2009 and the Gross enrolment ratio (%) in Marshall Islands in 2011?
Your response must be concise. -5.06. What is the difference between the Gross enrolment ratio (%) in Austria in 2009 and the Gross enrolment ratio (%) in Paraguay in 2011?
Your answer should be compact. 5.52. What is the difference between the Gross enrolment ratio (%) in Marshall Islands in 2009 and the Gross enrolment ratio (%) in Paraguay in 2011?
Provide a succinct answer. 12.83. What is the average Gross enrolment ratio (%) of High income per year?
Offer a very short reply. 102.08. What is the average Gross enrolment ratio (%) in Austria per year?
Provide a short and direct response. 100.5. What is the average Gross enrolment ratio (%) of Marshall Islands per year?
Your answer should be compact. 112.26. What is the average Gross enrolment ratio (%) in Paraguay per year?
Keep it short and to the point. 105.8. In the year 2003, what is the difference between the Gross enrolment ratio (%) in High income and Gross enrolment ratio (%) in Austria?
Your answer should be very brief. 2.58. In the year 2003, what is the difference between the Gross enrolment ratio (%) in High income and Gross enrolment ratio (%) in Marshall Islands?
Make the answer very short. -7.83. In the year 2003, what is the difference between the Gross enrolment ratio (%) of High income and Gross enrolment ratio (%) of Paraguay?
Your answer should be very brief. -11.09. In the year 2003, what is the difference between the Gross enrolment ratio (%) in Austria and Gross enrolment ratio (%) in Marshall Islands?
Provide a short and direct response. -10.41. In the year 2003, what is the difference between the Gross enrolment ratio (%) of Austria and Gross enrolment ratio (%) of Paraguay?
Your answer should be very brief. -13.67. In the year 2003, what is the difference between the Gross enrolment ratio (%) in Marshall Islands and Gross enrolment ratio (%) in Paraguay?
Provide a short and direct response. -3.26. In the year 2004, what is the difference between the Gross enrolment ratio (%) in High income and Gross enrolment ratio (%) in Austria?
Your response must be concise. 1.76. In the year 2004, what is the difference between the Gross enrolment ratio (%) in High income and Gross enrolment ratio (%) in Marshall Islands?
Ensure brevity in your answer.  -19.1. In the year 2004, what is the difference between the Gross enrolment ratio (%) of High income and Gross enrolment ratio (%) of Paraguay?
Your answer should be compact. -10.06. In the year 2004, what is the difference between the Gross enrolment ratio (%) of Austria and Gross enrolment ratio (%) of Marshall Islands?
Provide a short and direct response. -20.87. In the year 2004, what is the difference between the Gross enrolment ratio (%) of Austria and Gross enrolment ratio (%) of Paraguay?
Ensure brevity in your answer.  -11.82. In the year 2004, what is the difference between the Gross enrolment ratio (%) of Marshall Islands and Gross enrolment ratio (%) of Paraguay?
Provide a succinct answer. 9.05. In the year 2005, what is the difference between the Gross enrolment ratio (%) of High income and Gross enrolment ratio (%) of Austria?
Keep it short and to the point. 0.86. In the year 2005, what is the difference between the Gross enrolment ratio (%) in High income and Gross enrolment ratio (%) in Marshall Islands?
Offer a very short reply. -14.86. In the year 2005, what is the difference between the Gross enrolment ratio (%) of High income and Gross enrolment ratio (%) of Paraguay?
Ensure brevity in your answer.  -10.15. In the year 2005, what is the difference between the Gross enrolment ratio (%) of Austria and Gross enrolment ratio (%) of Marshall Islands?
Offer a terse response. -15.71. In the year 2005, what is the difference between the Gross enrolment ratio (%) in Austria and Gross enrolment ratio (%) in Paraguay?
Provide a short and direct response. -11.01. In the year 2005, what is the difference between the Gross enrolment ratio (%) of Marshall Islands and Gross enrolment ratio (%) of Paraguay?
Your response must be concise. 4.71. In the year 2006, what is the difference between the Gross enrolment ratio (%) of High income and Gross enrolment ratio (%) of Austria?
Offer a terse response. 0.22. In the year 2006, what is the difference between the Gross enrolment ratio (%) in High income and Gross enrolment ratio (%) in Marshall Islands?
Ensure brevity in your answer.  -14.14. In the year 2006, what is the difference between the Gross enrolment ratio (%) in High income and Gross enrolment ratio (%) in Paraguay?
Your answer should be compact. -6.69. In the year 2006, what is the difference between the Gross enrolment ratio (%) in Austria and Gross enrolment ratio (%) in Marshall Islands?
Make the answer very short. -14.36. In the year 2006, what is the difference between the Gross enrolment ratio (%) in Austria and Gross enrolment ratio (%) in Paraguay?
Make the answer very short. -6.92. In the year 2006, what is the difference between the Gross enrolment ratio (%) of Marshall Islands and Gross enrolment ratio (%) of Paraguay?
Your response must be concise. 7.44. In the year 2007, what is the difference between the Gross enrolment ratio (%) in High income and Gross enrolment ratio (%) in Austria?
Keep it short and to the point. 0.78. In the year 2007, what is the difference between the Gross enrolment ratio (%) in High income and Gross enrolment ratio (%) in Marshall Islands?
Keep it short and to the point. -9.91. In the year 2007, what is the difference between the Gross enrolment ratio (%) in High income and Gross enrolment ratio (%) in Paraguay?
Your answer should be compact. -3.06. In the year 2007, what is the difference between the Gross enrolment ratio (%) in Austria and Gross enrolment ratio (%) in Marshall Islands?
Your answer should be very brief. -10.69. In the year 2007, what is the difference between the Gross enrolment ratio (%) in Austria and Gross enrolment ratio (%) in Paraguay?
Offer a very short reply. -3.84. In the year 2007, what is the difference between the Gross enrolment ratio (%) in Marshall Islands and Gross enrolment ratio (%) in Paraguay?
Your response must be concise. 6.85. In the year 2008, what is the difference between the Gross enrolment ratio (%) in High income and Gross enrolment ratio (%) in Austria?
Give a very brief answer. 2.12. In the year 2008, what is the difference between the Gross enrolment ratio (%) in High income and Gross enrolment ratio (%) in Marshall Islands?
Your answer should be compact. -7.61. In the year 2008, what is the difference between the Gross enrolment ratio (%) in High income and Gross enrolment ratio (%) in Paraguay?
Your answer should be compact. 0.5. In the year 2008, what is the difference between the Gross enrolment ratio (%) of Austria and Gross enrolment ratio (%) of Marshall Islands?
Give a very brief answer. -9.72. In the year 2008, what is the difference between the Gross enrolment ratio (%) in Austria and Gross enrolment ratio (%) in Paraguay?
Offer a terse response. -1.61. In the year 2008, what is the difference between the Gross enrolment ratio (%) in Marshall Islands and Gross enrolment ratio (%) in Paraguay?
Give a very brief answer. 8.11. In the year 2009, what is the difference between the Gross enrolment ratio (%) in High income and Gross enrolment ratio (%) in Austria?
Your answer should be compact. 2.47. In the year 2009, what is the difference between the Gross enrolment ratio (%) of High income and Gross enrolment ratio (%) of Marshall Islands?
Provide a succinct answer. -4.84. In the year 2009, what is the difference between the Gross enrolment ratio (%) in High income and Gross enrolment ratio (%) in Paraguay?
Your response must be concise. 3.41. In the year 2009, what is the difference between the Gross enrolment ratio (%) in Austria and Gross enrolment ratio (%) in Marshall Islands?
Provide a succinct answer. -7.31. In the year 2009, what is the difference between the Gross enrolment ratio (%) of Austria and Gross enrolment ratio (%) of Paraguay?
Offer a very short reply. 0.94. In the year 2009, what is the difference between the Gross enrolment ratio (%) in Marshall Islands and Gross enrolment ratio (%) in Paraguay?
Ensure brevity in your answer.  8.24. In the year 2011, what is the difference between the Gross enrolment ratio (%) of High income and Gross enrolment ratio (%) of Austria?
Give a very brief answer. 1.84. In the year 2011, what is the difference between the Gross enrolment ratio (%) of High income and Gross enrolment ratio (%) of Marshall Islands?
Your answer should be compact. -3.19. In the year 2011, what is the difference between the Gross enrolment ratio (%) in High income and Gross enrolment ratio (%) in Paraguay?
Ensure brevity in your answer.  7.39. In the year 2011, what is the difference between the Gross enrolment ratio (%) of Austria and Gross enrolment ratio (%) of Marshall Islands?
Keep it short and to the point. -5.03. In the year 2011, what is the difference between the Gross enrolment ratio (%) in Austria and Gross enrolment ratio (%) in Paraguay?
Offer a very short reply. 5.55. In the year 2011, what is the difference between the Gross enrolment ratio (%) in Marshall Islands and Gross enrolment ratio (%) in Paraguay?
Offer a terse response. 10.58. What is the ratio of the Gross enrolment ratio (%) in Austria in 2003 to that in 2004?
Provide a succinct answer. 0.99. What is the ratio of the Gross enrolment ratio (%) in Marshall Islands in 2003 to that in 2004?
Give a very brief answer. 0.91. What is the ratio of the Gross enrolment ratio (%) in Paraguay in 2003 to that in 2004?
Give a very brief answer. 1.01. What is the ratio of the Gross enrolment ratio (%) of High income in 2003 to that in 2005?
Your response must be concise. 1.01. What is the ratio of the Gross enrolment ratio (%) in Austria in 2003 to that in 2005?
Ensure brevity in your answer.  0.99. What is the ratio of the Gross enrolment ratio (%) in Marshall Islands in 2003 to that in 2005?
Give a very brief answer. 0.95. What is the ratio of the Gross enrolment ratio (%) of Paraguay in 2003 to that in 2005?
Make the answer very short. 1.01. What is the ratio of the Gross enrolment ratio (%) of High income in 2003 to that in 2006?
Offer a terse response. 1. What is the ratio of the Gross enrolment ratio (%) in Austria in 2003 to that in 2006?
Give a very brief answer. 0.98. What is the ratio of the Gross enrolment ratio (%) of Marshall Islands in 2003 to that in 2006?
Provide a succinct answer. 0.95. What is the ratio of the Gross enrolment ratio (%) in Paraguay in 2003 to that in 2006?
Your answer should be compact. 1.04. What is the ratio of the Gross enrolment ratio (%) of Marshall Islands in 2003 to that in 2007?
Offer a terse response. 0.98. What is the ratio of the Gross enrolment ratio (%) in Paraguay in 2003 to that in 2007?
Ensure brevity in your answer.  1.07. What is the ratio of the Gross enrolment ratio (%) of High income in 2003 to that in 2008?
Keep it short and to the point. 0.99. What is the ratio of the Gross enrolment ratio (%) of Austria in 2003 to that in 2008?
Keep it short and to the point. 0.99. What is the ratio of the Gross enrolment ratio (%) of Paraguay in 2003 to that in 2008?
Give a very brief answer. 1.1. What is the ratio of the Gross enrolment ratio (%) in High income in 2003 to that in 2009?
Offer a terse response. 0.99. What is the ratio of the Gross enrolment ratio (%) of Marshall Islands in 2003 to that in 2009?
Offer a terse response. 1.02. What is the ratio of the Gross enrolment ratio (%) of Paraguay in 2003 to that in 2009?
Offer a terse response. 1.14. What is the ratio of the Gross enrolment ratio (%) in Austria in 2003 to that in 2011?
Your answer should be very brief. 0.99. What is the ratio of the Gross enrolment ratio (%) of Marshall Islands in 2003 to that in 2011?
Keep it short and to the point. 1.04. What is the ratio of the Gross enrolment ratio (%) of Paraguay in 2003 to that in 2011?
Give a very brief answer. 1.19. What is the ratio of the Gross enrolment ratio (%) in Austria in 2004 to that in 2005?
Your answer should be compact. 1. What is the ratio of the Gross enrolment ratio (%) of Marshall Islands in 2004 to that in 2005?
Offer a very short reply. 1.04. What is the ratio of the Gross enrolment ratio (%) in Paraguay in 2004 to that in 2005?
Provide a succinct answer. 1. What is the ratio of the Gross enrolment ratio (%) of High income in 2004 to that in 2006?
Offer a terse response. 1. What is the ratio of the Gross enrolment ratio (%) in Austria in 2004 to that in 2006?
Your answer should be compact. 0.98. What is the ratio of the Gross enrolment ratio (%) of Marshall Islands in 2004 to that in 2006?
Give a very brief answer. 1.04. What is the ratio of the Gross enrolment ratio (%) of Paraguay in 2004 to that in 2006?
Keep it short and to the point. 1.03. What is the ratio of the Gross enrolment ratio (%) of High income in 2004 to that in 2007?
Give a very brief answer. 0.99. What is the ratio of the Gross enrolment ratio (%) in Austria in 2004 to that in 2007?
Offer a terse response. 0.98. What is the ratio of the Gross enrolment ratio (%) in Marshall Islands in 2004 to that in 2007?
Offer a very short reply. 1.08. What is the ratio of the Gross enrolment ratio (%) of Paraguay in 2004 to that in 2007?
Ensure brevity in your answer.  1.06. What is the ratio of the Gross enrolment ratio (%) of Austria in 2004 to that in 2008?
Provide a succinct answer. 0.99. What is the ratio of the Gross enrolment ratio (%) in Marshall Islands in 2004 to that in 2008?
Provide a short and direct response. 1.09. What is the ratio of the Gross enrolment ratio (%) of Paraguay in 2004 to that in 2008?
Make the answer very short. 1.09. What is the ratio of the Gross enrolment ratio (%) of High income in 2004 to that in 2009?
Your response must be concise. 0.99. What is the ratio of the Gross enrolment ratio (%) in Austria in 2004 to that in 2009?
Your response must be concise. 1. What is the ratio of the Gross enrolment ratio (%) in Marshall Islands in 2004 to that in 2009?
Ensure brevity in your answer.  1.12. What is the ratio of the Gross enrolment ratio (%) in Paraguay in 2004 to that in 2009?
Keep it short and to the point. 1.12. What is the ratio of the Gross enrolment ratio (%) of High income in 2004 to that in 2011?
Make the answer very short. 0.99. What is the ratio of the Gross enrolment ratio (%) of Marshall Islands in 2004 to that in 2011?
Keep it short and to the point. 1.15. What is the ratio of the Gross enrolment ratio (%) of Paraguay in 2004 to that in 2011?
Your response must be concise. 1.18. What is the ratio of the Gross enrolment ratio (%) in High income in 2005 to that in 2006?
Keep it short and to the point. 1. What is the ratio of the Gross enrolment ratio (%) of Austria in 2005 to that in 2006?
Offer a very short reply. 0.99. What is the ratio of the Gross enrolment ratio (%) in Marshall Islands in 2005 to that in 2006?
Give a very brief answer. 1. What is the ratio of the Gross enrolment ratio (%) of Paraguay in 2005 to that in 2006?
Make the answer very short. 1.03. What is the ratio of the Gross enrolment ratio (%) in High income in 2005 to that in 2007?
Ensure brevity in your answer.  0.99. What is the ratio of the Gross enrolment ratio (%) in Marshall Islands in 2005 to that in 2007?
Provide a succinct answer. 1.03. What is the ratio of the Gross enrolment ratio (%) of Paraguay in 2005 to that in 2007?
Offer a very short reply. 1.06. What is the ratio of the Gross enrolment ratio (%) in High income in 2005 to that in 2008?
Your response must be concise. 0.98. What is the ratio of the Gross enrolment ratio (%) of Austria in 2005 to that in 2008?
Give a very brief answer. 1. What is the ratio of the Gross enrolment ratio (%) of Marshall Islands in 2005 to that in 2008?
Give a very brief answer. 1.05. What is the ratio of the Gross enrolment ratio (%) of Paraguay in 2005 to that in 2008?
Give a very brief answer. 1.09. What is the ratio of the Gross enrolment ratio (%) in High income in 2005 to that in 2009?
Offer a terse response. 0.98. What is the ratio of the Gross enrolment ratio (%) of Austria in 2005 to that in 2009?
Give a very brief answer. 1. What is the ratio of the Gross enrolment ratio (%) of Marshall Islands in 2005 to that in 2009?
Give a very brief answer. 1.08. What is the ratio of the Gross enrolment ratio (%) of Paraguay in 2005 to that in 2009?
Offer a terse response. 1.12. What is the ratio of the Gross enrolment ratio (%) in High income in 2005 to that in 2011?
Give a very brief answer. 0.99. What is the ratio of the Gross enrolment ratio (%) of Austria in 2005 to that in 2011?
Your answer should be very brief. 1. What is the ratio of the Gross enrolment ratio (%) of Marshall Islands in 2005 to that in 2011?
Ensure brevity in your answer.  1.1. What is the ratio of the Gross enrolment ratio (%) in Paraguay in 2005 to that in 2011?
Provide a short and direct response. 1.17. What is the ratio of the Gross enrolment ratio (%) of High income in 2006 to that in 2007?
Provide a succinct answer. 0.99. What is the ratio of the Gross enrolment ratio (%) of Austria in 2006 to that in 2007?
Your answer should be very brief. 1. What is the ratio of the Gross enrolment ratio (%) of Marshall Islands in 2006 to that in 2007?
Ensure brevity in your answer.  1.03. What is the ratio of the Gross enrolment ratio (%) in Paraguay in 2006 to that in 2007?
Your answer should be very brief. 1.03. What is the ratio of the Gross enrolment ratio (%) of Austria in 2006 to that in 2008?
Make the answer very short. 1.01. What is the ratio of the Gross enrolment ratio (%) of Marshall Islands in 2006 to that in 2008?
Your response must be concise. 1.05. What is the ratio of the Gross enrolment ratio (%) of Paraguay in 2006 to that in 2008?
Your answer should be compact. 1.06. What is the ratio of the Gross enrolment ratio (%) of High income in 2006 to that in 2009?
Make the answer very short. 0.99. What is the ratio of the Gross enrolment ratio (%) in Austria in 2006 to that in 2009?
Offer a very short reply. 1.01. What is the ratio of the Gross enrolment ratio (%) in Marshall Islands in 2006 to that in 2009?
Ensure brevity in your answer.  1.08. What is the ratio of the Gross enrolment ratio (%) in Paraguay in 2006 to that in 2009?
Offer a terse response. 1.09. What is the ratio of the Gross enrolment ratio (%) in High income in 2006 to that in 2011?
Keep it short and to the point. 0.99. What is the ratio of the Gross enrolment ratio (%) of Austria in 2006 to that in 2011?
Your answer should be compact. 1.01. What is the ratio of the Gross enrolment ratio (%) of Marshall Islands in 2006 to that in 2011?
Your answer should be compact. 1.1. What is the ratio of the Gross enrolment ratio (%) of Paraguay in 2006 to that in 2011?
Give a very brief answer. 1.14. What is the ratio of the Gross enrolment ratio (%) of High income in 2007 to that in 2008?
Provide a short and direct response. 1. What is the ratio of the Gross enrolment ratio (%) of Austria in 2007 to that in 2008?
Keep it short and to the point. 1.01. What is the ratio of the Gross enrolment ratio (%) in Marshall Islands in 2007 to that in 2008?
Give a very brief answer. 1.02. What is the ratio of the Gross enrolment ratio (%) in Paraguay in 2007 to that in 2008?
Your answer should be compact. 1.03. What is the ratio of the Gross enrolment ratio (%) of Austria in 2007 to that in 2009?
Provide a short and direct response. 1.01. What is the ratio of the Gross enrolment ratio (%) in Marshall Islands in 2007 to that in 2009?
Your answer should be compact. 1.04. What is the ratio of the Gross enrolment ratio (%) of Paraguay in 2007 to that in 2009?
Provide a succinct answer. 1.06. What is the ratio of the Gross enrolment ratio (%) of High income in 2007 to that in 2011?
Provide a succinct answer. 1. What is the ratio of the Gross enrolment ratio (%) in Austria in 2007 to that in 2011?
Provide a short and direct response. 1.01. What is the ratio of the Gross enrolment ratio (%) of Marshall Islands in 2007 to that in 2011?
Keep it short and to the point. 1.07. What is the ratio of the Gross enrolment ratio (%) of Paraguay in 2007 to that in 2011?
Make the answer very short. 1.11. What is the ratio of the Gross enrolment ratio (%) of High income in 2008 to that in 2009?
Provide a succinct answer. 1. What is the ratio of the Gross enrolment ratio (%) of Austria in 2008 to that in 2009?
Keep it short and to the point. 1. What is the ratio of the Gross enrolment ratio (%) in Marshall Islands in 2008 to that in 2009?
Your answer should be compact. 1.03. What is the ratio of the Gross enrolment ratio (%) of Paraguay in 2008 to that in 2009?
Your answer should be very brief. 1.03. What is the ratio of the Gross enrolment ratio (%) in High income in 2008 to that in 2011?
Offer a very short reply. 1.01. What is the ratio of the Gross enrolment ratio (%) of Marshall Islands in 2008 to that in 2011?
Provide a short and direct response. 1.05. What is the ratio of the Gross enrolment ratio (%) in Paraguay in 2008 to that in 2011?
Ensure brevity in your answer.  1.08. What is the ratio of the Gross enrolment ratio (%) in High income in 2009 to that in 2011?
Ensure brevity in your answer.  1.01. What is the ratio of the Gross enrolment ratio (%) of Austria in 2009 to that in 2011?
Your answer should be very brief. 1. What is the ratio of the Gross enrolment ratio (%) in Marshall Islands in 2009 to that in 2011?
Give a very brief answer. 1.02. What is the ratio of the Gross enrolment ratio (%) in Paraguay in 2009 to that in 2011?
Provide a short and direct response. 1.05. What is the difference between the highest and the second highest Gross enrolment ratio (%) in High income?
Offer a very short reply. 0.03. What is the difference between the highest and the second highest Gross enrolment ratio (%) in Austria?
Ensure brevity in your answer.  0.15. What is the difference between the highest and the second highest Gross enrolment ratio (%) of Marshall Islands?
Make the answer very short. 4.67. What is the difference between the highest and the second highest Gross enrolment ratio (%) of Paraguay?
Provide a succinct answer. 1.34. What is the difference between the highest and the lowest Gross enrolment ratio (%) in High income?
Provide a succinct answer. 1.65. What is the difference between the highest and the lowest Gross enrolment ratio (%) of Austria?
Your answer should be very brief. 2.23. What is the difference between the highest and the lowest Gross enrolment ratio (%) in Marshall Islands?
Give a very brief answer. 15.32. What is the difference between the highest and the lowest Gross enrolment ratio (%) of Paraguay?
Your answer should be very brief. 18.19. 